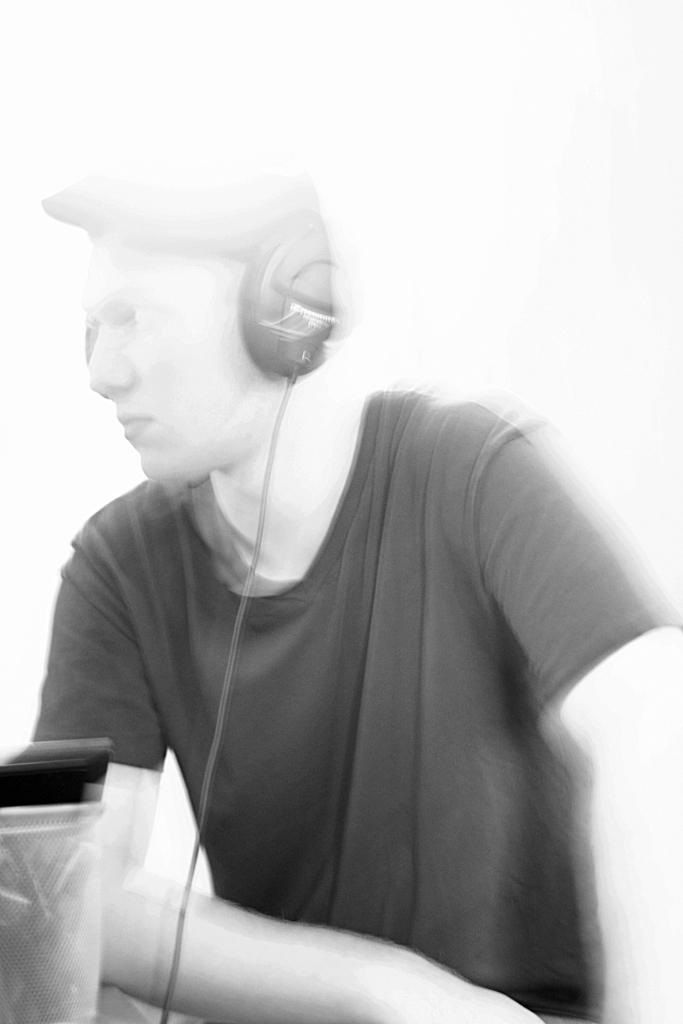Who is present in the image? There is a person in the image. What is the person wearing? The person is wearing headphones. What object can be seen on the left side of the image? There is a box on the left side of the image. What is inside the box? There are pens inside the box. What holiday is being celebrated in the image? There is no indication of a holiday being celebrated in the image. What type of teaching is happening in the image? There is no teaching activity depicted in the image. 